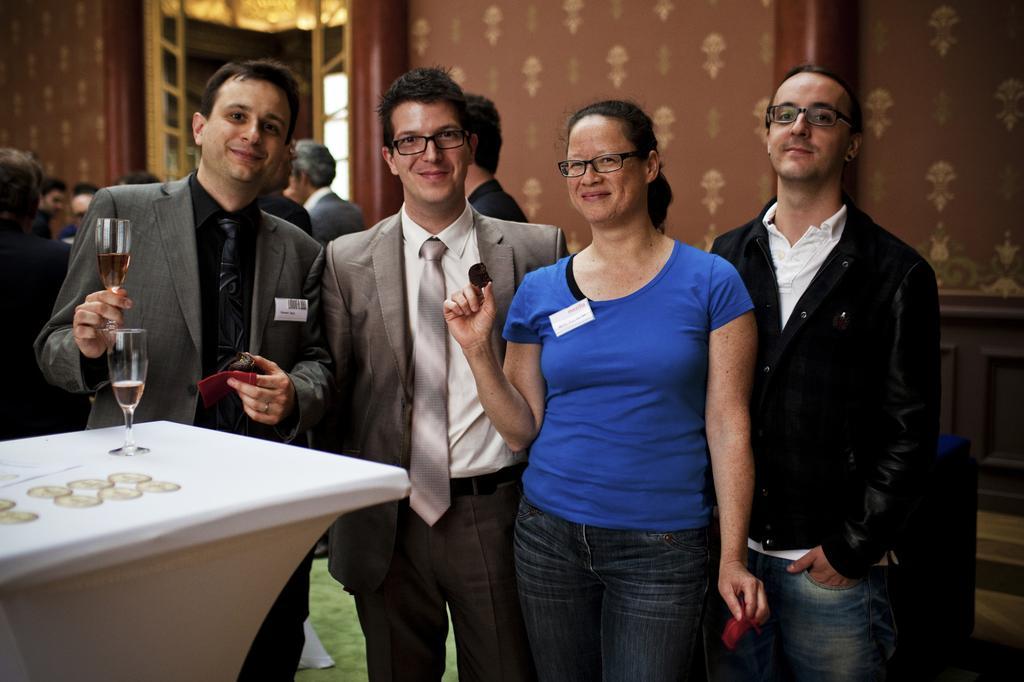Please provide a concise description of this image. In this picture we can see four persons some of them were spectacle, tie, blazer and hear the person holding glass in his hand and in front of them we have table and on table we have glass, some coins and in the background we can see group of people, wall, door. 